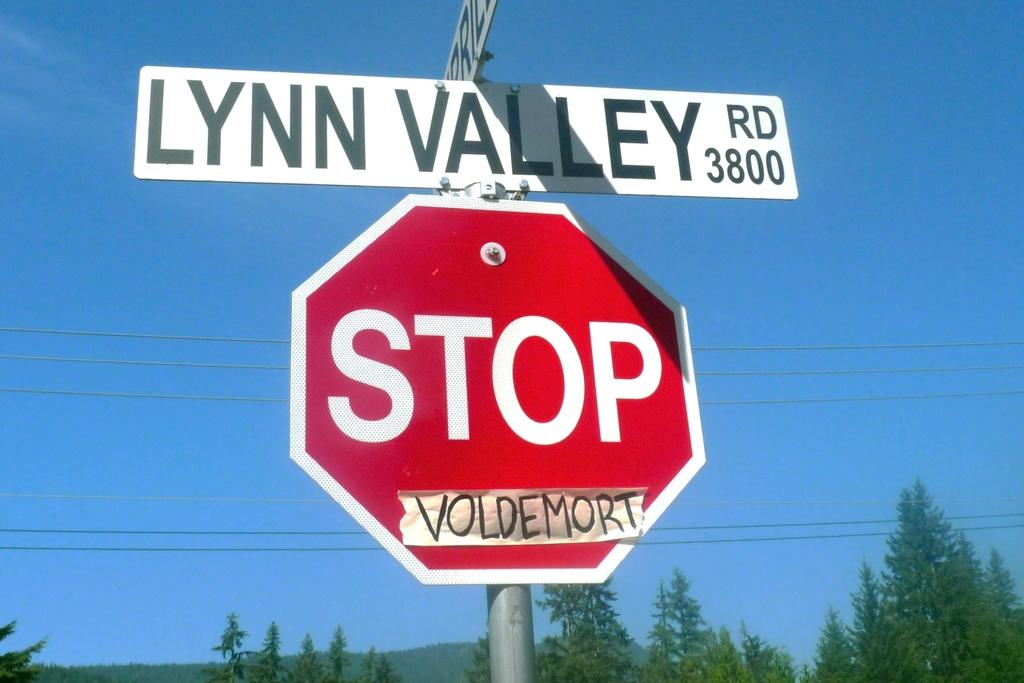<image>
Create a compact narrative representing the image presented. The sign for Lynn Valley Road has a stop sign just below it. 